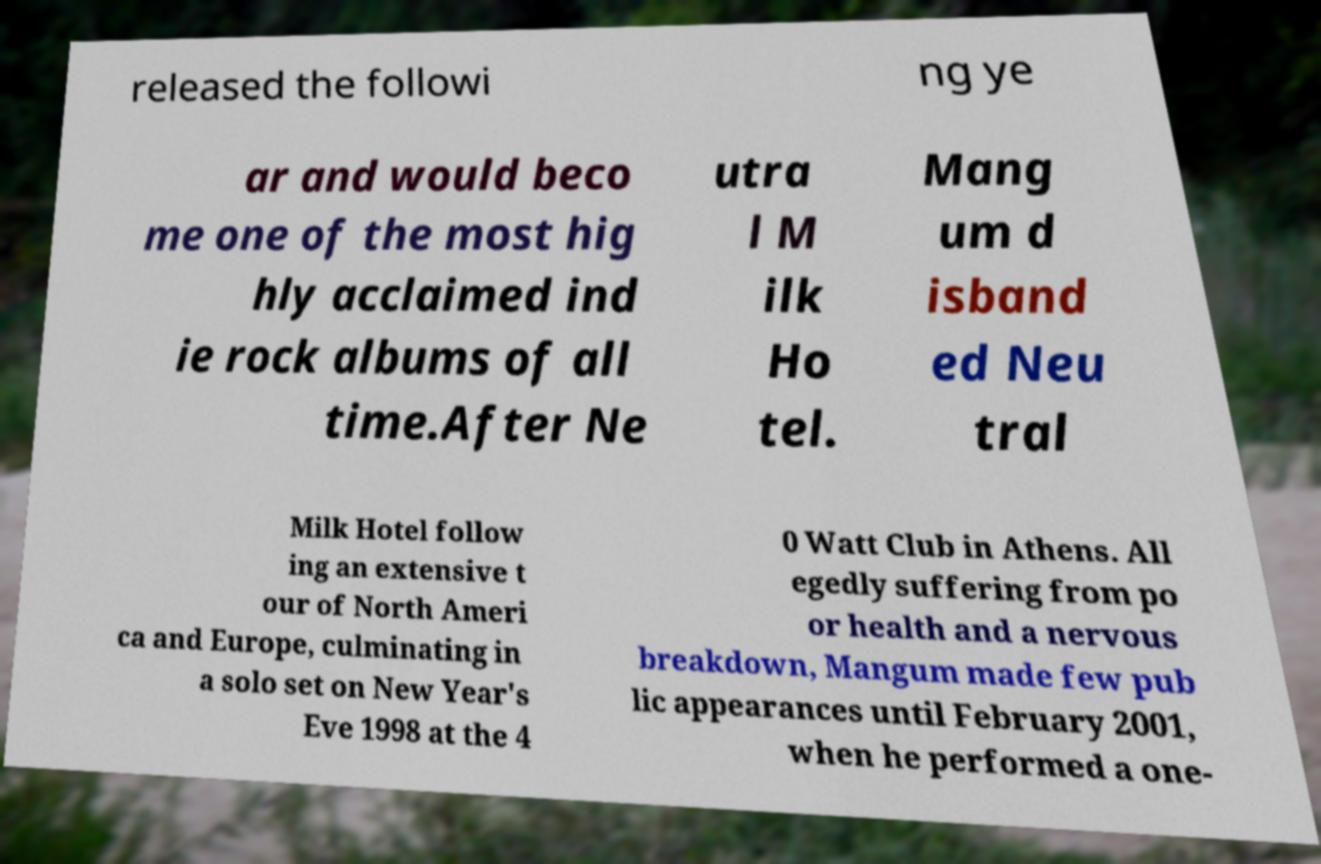Can you accurately transcribe the text from the provided image for me? released the followi ng ye ar and would beco me one of the most hig hly acclaimed ind ie rock albums of all time.After Ne utra l M ilk Ho tel. Mang um d isband ed Neu tral Milk Hotel follow ing an extensive t our of North Ameri ca and Europe, culminating in a solo set on New Year's Eve 1998 at the 4 0 Watt Club in Athens. All egedly suffering from po or health and a nervous breakdown, Mangum made few pub lic appearances until February 2001, when he performed a one- 